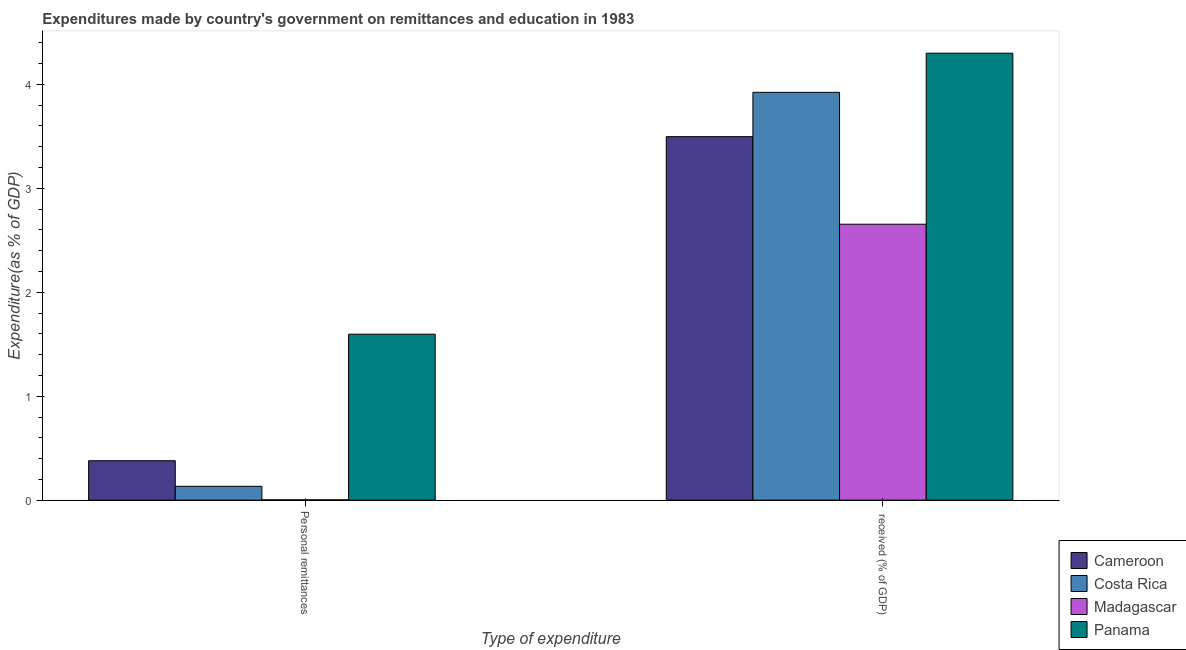How many different coloured bars are there?
Your answer should be very brief. 4. How many groups of bars are there?
Your response must be concise. 2. Are the number of bars per tick equal to the number of legend labels?
Make the answer very short. Yes. How many bars are there on the 2nd tick from the left?
Ensure brevity in your answer.  4. How many bars are there on the 2nd tick from the right?
Ensure brevity in your answer.  4. What is the label of the 1st group of bars from the left?
Keep it short and to the point. Personal remittances. What is the expenditure in education in Panama?
Give a very brief answer. 4.3. Across all countries, what is the maximum expenditure in personal remittances?
Your answer should be compact. 1.6. Across all countries, what is the minimum expenditure in personal remittances?
Offer a terse response. 0. In which country was the expenditure in personal remittances maximum?
Offer a terse response. Panama. In which country was the expenditure in personal remittances minimum?
Offer a terse response. Madagascar. What is the total expenditure in education in the graph?
Provide a succinct answer. 14.37. What is the difference between the expenditure in education in Panama and that in Costa Rica?
Ensure brevity in your answer.  0.38. What is the difference between the expenditure in personal remittances in Cameroon and the expenditure in education in Costa Rica?
Provide a short and direct response. -3.54. What is the average expenditure in education per country?
Your answer should be compact. 3.59. What is the difference between the expenditure in education and expenditure in personal remittances in Panama?
Provide a short and direct response. 2.7. In how many countries, is the expenditure in personal remittances greater than 2.6 %?
Provide a succinct answer. 0. What is the ratio of the expenditure in education in Panama to that in Cameroon?
Your response must be concise. 1.23. What does the 3rd bar from the left in Personal remittances represents?
Offer a very short reply. Madagascar. What does the 3rd bar from the right in Personal remittances represents?
Your answer should be compact. Costa Rica. How many bars are there?
Offer a terse response. 8. Are all the bars in the graph horizontal?
Provide a succinct answer. No. What is the difference between two consecutive major ticks on the Y-axis?
Offer a very short reply. 1. Are the values on the major ticks of Y-axis written in scientific E-notation?
Offer a very short reply. No. Does the graph contain any zero values?
Make the answer very short. No. What is the title of the graph?
Provide a short and direct response. Expenditures made by country's government on remittances and education in 1983. Does "Niger" appear as one of the legend labels in the graph?
Your response must be concise. No. What is the label or title of the X-axis?
Offer a terse response. Type of expenditure. What is the label or title of the Y-axis?
Provide a short and direct response. Expenditure(as % of GDP). What is the Expenditure(as % of GDP) of Cameroon in Personal remittances?
Your answer should be compact. 0.38. What is the Expenditure(as % of GDP) of Costa Rica in Personal remittances?
Offer a terse response. 0.13. What is the Expenditure(as % of GDP) of Madagascar in Personal remittances?
Offer a terse response. 0. What is the Expenditure(as % of GDP) in Panama in Personal remittances?
Give a very brief answer. 1.6. What is the Expenditure(as % of GDP) in Cameroon in  received (% of GDP)?
Your answer should be very brief. 3.5. What is the Expenditure(as % of GDP) in Costa Rica in  received (% of GDP)?
Make the answer very short. 3.92. What is the Expenditure(as % of GDP) in Madagascar in  received (% of GDP)?
Ensure brevity in your answer.  2.65. What is the Expenditure(as % of GDP) in Panama in  received (% of GDP)?
Your answer should be very brief. 4.3. Across all Type of expenditure, what is the maximum Expenditure(as % of GDP) of Cameroon?
Provide a succinct answer. 3.5. Across all Type of expenditure, what is the maximum Expenditure(as % of GDP) of Costa Rica?
Your response must be concise. 3.92. Across all Type of expenditure, what is the maximum Expenditure(as % of GDP) in Madagascar?
Make the answer very short. 2.65. Across all Type of expenditure, what is the maximum Expenditure(as % of GDP) of Panama?
Offer a terse response. 4.3. Across all Type of expenditure, what is the minimum Expenditure(as % of GDP) in Cameroon?
Give a very brief answer. 0.38. Across all Type of expenditure, what is the minimum Expenditure(as % of GDP) of Costa Rica?
Your answer should be very brief. 0.13. Across all Type of expenditure, what is the minimum Expenditure(as % of GDP) in Madagascar?
Provide a succinct answer. 0. Across all Type of expenditure, what is the minimum Expenditure(as % of GDP) in Panama?
Your response must be concise. 1.6. What is the total Expenditure(as % of GDP) of Cameroon in the graph?
Offer a terse response. 3.88. What is the total Expenditure(as % of GDP) of Costa Rica in the graph?
Offer a terse response. 4.06. What is the total Expenditure(as % of GDP) of Madagascar in the graph?
Your answer should be compact. 2.66. What is the total Expenditure(as % of GDP) in Panama in the graph?
Your answer should be very brief. 5.9. What is the difference between the Expenditure(as % of GDP) of Cameroon in Personal remittances and that in  received (% of GDP)?
Offer a very short reply. -3.12. What is the difference between the Expenditure(as % of GDP) in Costa Rica in Personal remittances and that in  received (% of GDP)?
Give a very brief answer. -3.79. What is the difference between the Expenditure(as % of GDP) of Madagascar in Personal remittances and that in  received (% of GDP)?
Your answer should be compact. -2.65. What is the difference between the Expenditure(as % of GDP) in Panama in Personal remittances and that in  received (% of GDP)?
Offer a terse response. -2.7. What is the difference between the Expenditure(as % of GDP) in Cameroon in Personal remittances and the Expenditure(as % of GDP) in Costa Rica in  received (% of GDP)?
Ensure brevity in your answer.  -3.54. What is the difference between the Expenditure(as % of GDP) of Cameroon in Personal remittances and the Expenditure(as % of GDP) of Madagascar in  received (% of GDP)?
Your response must be concise. -2.28. What is the difference between the Expenditure(as % of GDP) in Cameroon in Personal remittances and the Expenditure(as % of GDP) in Panama in  received (% of GDP)?
Keep it short and to the point. -3.92. What is the difference between the Expenditure(as % of GDP) in Costa Rica in Personal remittances and the Expenditure(as % of GDP) in Madagascar in  received (% of GDP)?
Keep it short and to the point. -2.52. What is the difference between the Expenditure(as % of GDP) of Costa Rica in Personal remittances and the Expenditure(as % of GDP) of Panama in  received (% of GDP)?
Give a very brief answer. -4.17. What is the difference between the Expenditure(as % of GDP) in Madagascar in Personal remittances and the Expenditure(as % of GDP) in Panama in  received (% of GDP)?
Provide a short and direct response. -4.3. What is the average Expenditure(as % of GDP) in Cameroon per Type of expenditure?
Make the answer very short. 1.94. What is the average Expenditure(as % of GDP) in Costa Rica per Type of expenditure?
Your response must be concise. 2.03. What is the average Expenditure(as % of GDP) of Madagascar per Type of expenditure?
Keep it short and to the point. 1.33. What is the average Expenditure(as % of GDP) of Panama per Type of expenditure?
Your answer should be very brief. 2.95. What is the difference between the Expenditure(as % of GDP) in Cameroon and Expenditure(as % of GDP) in Costa Rica in Personal remittances?
Keep it short and to the point. 0.25. What is the difference between the Expenditure(as % of GDP) of Cameroon and Expenditure(as % of GDP) of Madagascar in Personal remittances?
Provide a short and direct response. 0.38. What is the difference between the Expenditure(as % of GDP) of Cameroon and Expenditure(as % of GDP) of Panama in Personal remittances?
Offer a very short reply. -1.22. What is the difference between the Expenditure(as % of GDP) in Costa Rica and Expenditure(as % of GDP) in Madagascar in Personal remittances?
Ensure brevity in your answer.  0.13. What is the difference between the Expenditure(as % of GDP) in Costa Rica and Expenditure(as % of GDP) in Panama in Personal remittances?
Ensure brevity in your answer.  -1.46. What is the difference between the Expenditure(as % of GDP) in Madagascar and Expenditure(as % of GDP) in Panama in Personal remittances?
Provide a succinct answer. -1.59. What is the difference between the Expenditure(as % of GDP) of Cameroon and Expenditure(as % of GDP) of Costa Rica in  received (% of GDP)?
Your answer should be very brief. -0.43. What is the difference between the Expenditure(as % of GDP) of Cameroon and Expenditure(as % of GDP) of Madagascar in  received (% of GDP)?
Your answer should be very brief. 0.84. What is the difference between the Expenditure(as % of GDP) in Cameroon and Expenditure(as % of GDP) in Panama in  received (% of GDP)?
Offer a very short reply. -0.8. What is the difference between the Expenditure(as % of GDP) of Costa Rica and Expenditure(as % of GDP) of Madagascar in  received (% of GDP)?
Ensure brevity in your answer.  1.27. What is the difference between the Expenditure(as % of GDP) of Costa Rica and Expenditure(as % of GDP) of Panama in  received (% of GDP)?
Offer a terse response. -0.38. What is the difference between the Expenditure(as % of GDP) of Madagascar and Expenditure(as % of GDP) of Panama in  received (% of GDP)?
Your response must be concise. -1.65. What is the ratio of the Expenditure(as % of GDP) of Cameroon in Personal remittances to that in  received (% of GDP)?
Your answer should be compact. 0.11. What is the ratio of the Expenditure(as % of GDP) of Costa Rica in Personal remittances to that in  received (% of GDP)?
Provide a succinct answer. 0.03. What is the ratio of the Expenditure(as % of GDP) of Madagascar in Personal remittances to that in  received (% of GDP)?
Your answer should be compact. 0. What is the ratio of the Expenditure(as % of GDP) in Panama in Personal remittances to that in  received (% of GDP)?
Offer a terse response. 0.37. What is the difference between the highest and the second highest Expenditure(as % of GDP) of Cameroon?
Give a very brief answer. 3.12. What is the difference between the highest and the second highest Expenditure(as % of GDP) in Costa Rica?
Your answer should be compact. 3.79. What is the difference between the highest and the second highest Expenditure(as % of GDP) of Madagascar?
Offer a very short reply. 2.65. What is the difference between the highest and the second highest Expenditure(as % of GDP) of Panama?
Provide a short and direct response. 2.7. What is the difference between the highest and the lowest Expenditure(as % of GDP) in Cameroon?
Provide a short and direct response. 3.12. What is the difference between the highest and the lowest Expenditure(as % of GDP) of Costa Rica?
Provide a succinct answer. 3.79. What is the difference between the highest and the lowest Expenditure(as % of GDP) of Madagascar?
Make the answer very short. 2.65. What is the difference between the highest and the lowest Expenditure(as % of GDP) of Panama?
Ensure brevity in your answer.  2.7. 